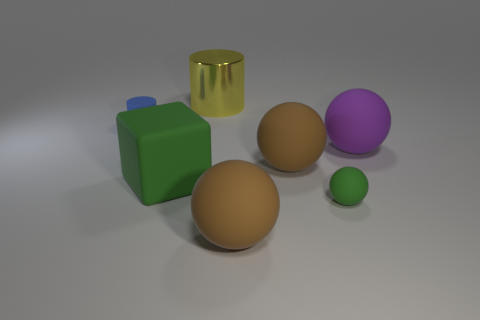Add 1 big blue spheres. How many objects exist? 8 Subtract all cylinders. How many objects are left? 5 Subtract 0 blue cubes. How many objects are left? 7 Subtract all small brown rubber blocks. Subtract all large green matte blocks. How many objects are left? 6 Add 3 cylinders. How many cylinders are left? 5 Add 4 yellow metallic cylinders. How many yellow metallic cylinders exist? 5 